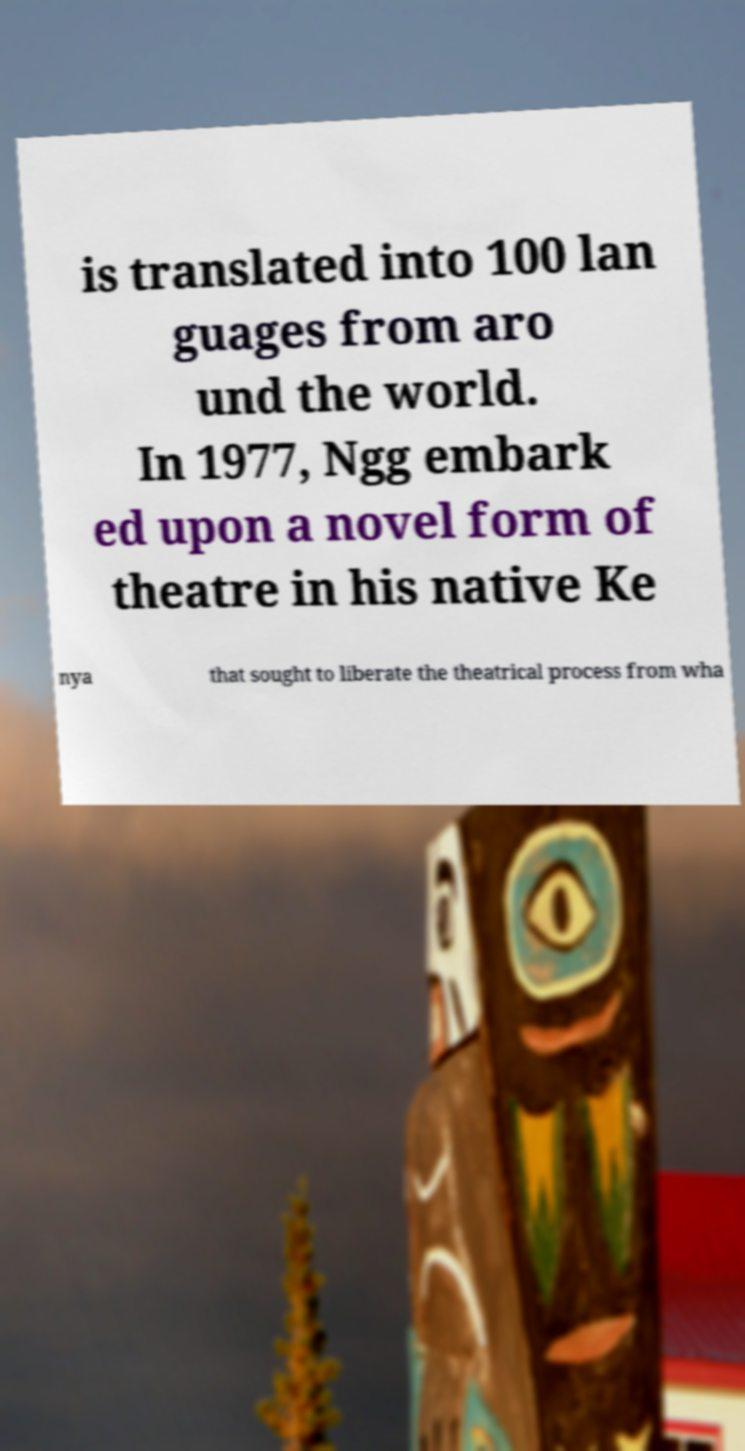For documentation purposes, I need the text within this image transcribed. Could you provide that? is translated into 100 lan guages from aro und the world. In 1977, Ngg embark ed upon a novel form of theatre in his native Ke nya that sought to liberate the theatrical process from wha 